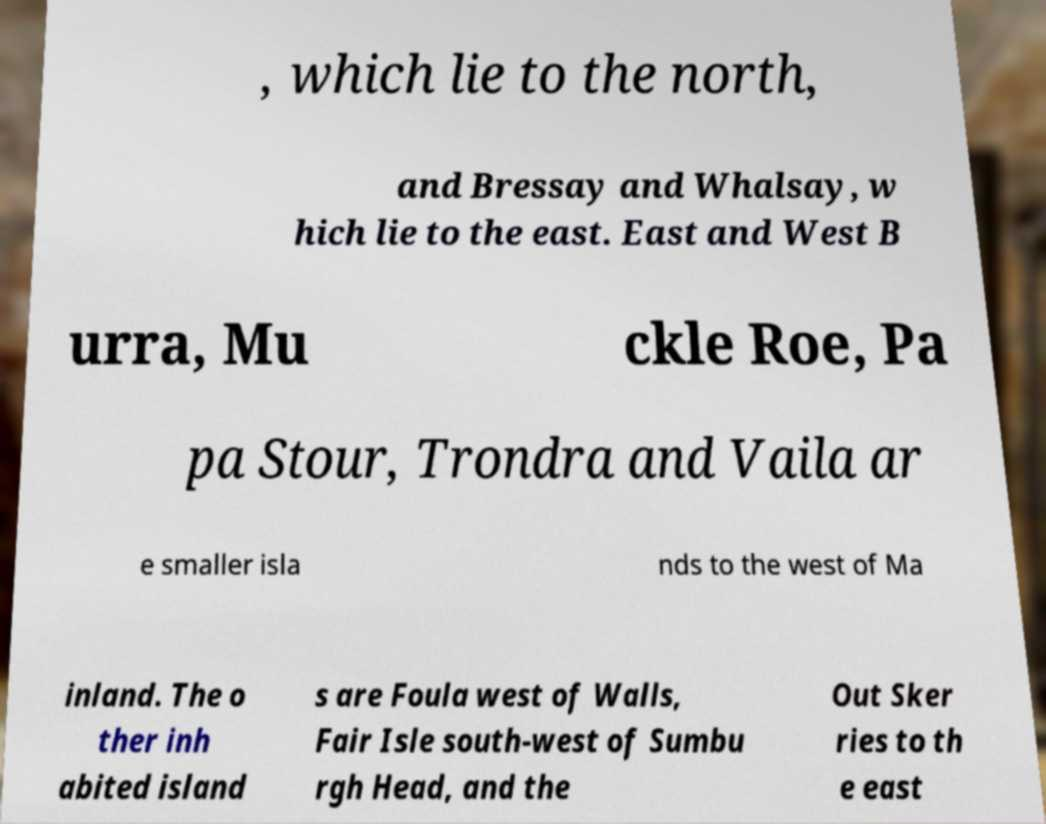There's text embedded in this image that I need extracted. Can you transcribe it verbatim? , which lie to the north, and Bressay and Whalsay, w hich lie to the east. East and West B urra, Mu ckle Roe, Pa pa Stour, Trondra and Vaila ar e smaller isla nds to the west of Ma inland. The o ther inh abited island s are Foula west of Walls, Fair Isle south-west of Sumbu rgh Head, and the Out Sker ries to th e east 